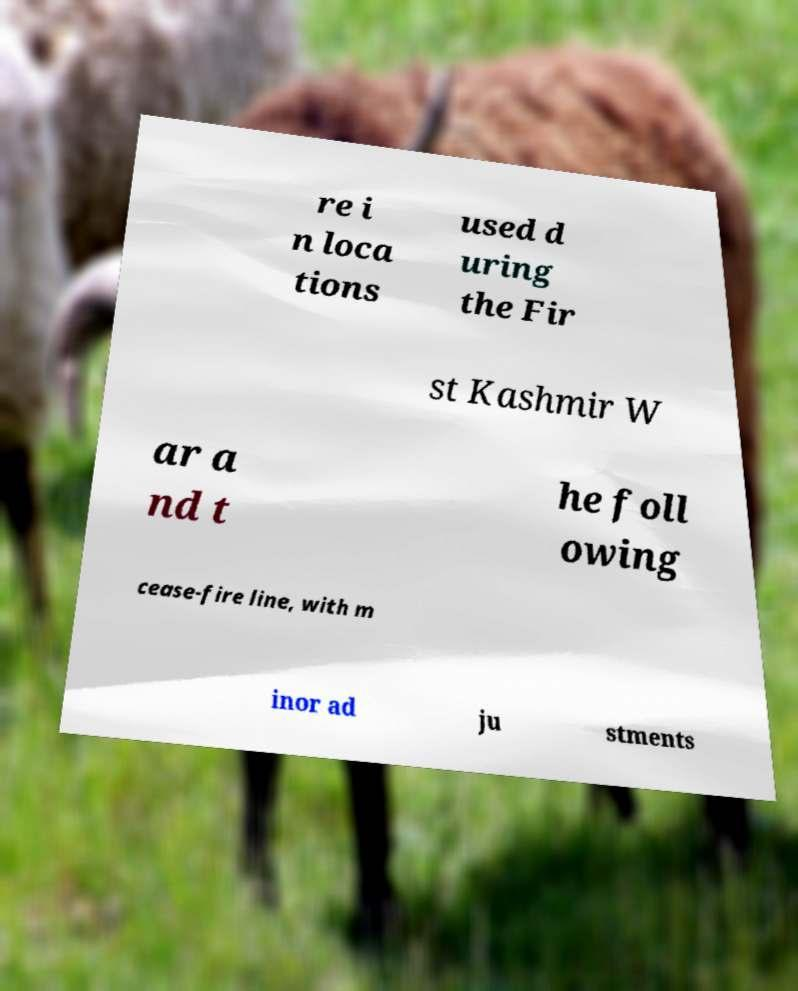I need the written content from this picture converted into text. Can you do that? re i n loca tions used d uring the Fir st Kashmir W ar a nd t he foll owing cease-fire line, with m inor ad ju stments 